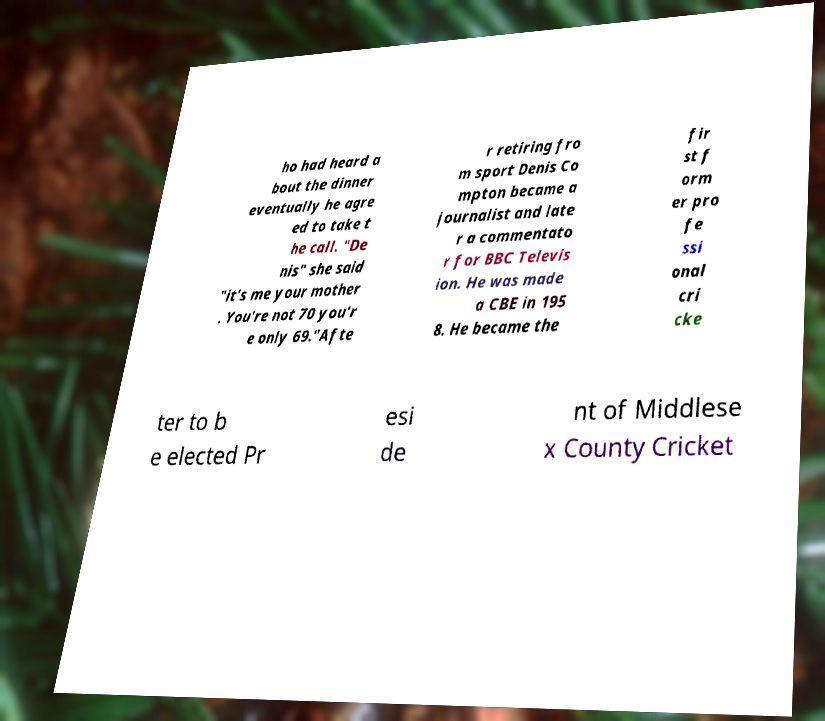Can you read and provide the text displayed in the image?This photo seems to have some interesting text. Can you extract and type it out for me? ho had heard a bout the dinner eventually he agre ed to take t he call. "De nis" she said "it's me your mother . You're not 70 you'r e only 69."Afte r retiring fro m sport Denis Co mpton became a journalist and late r a commentato r for BBC Televis ion. He was made a CBE in 195 8. He became the fir st f orm er pro fe ssi onal cri cke ter to b e elected Pr esi de nt of Middlese x County Cricket 